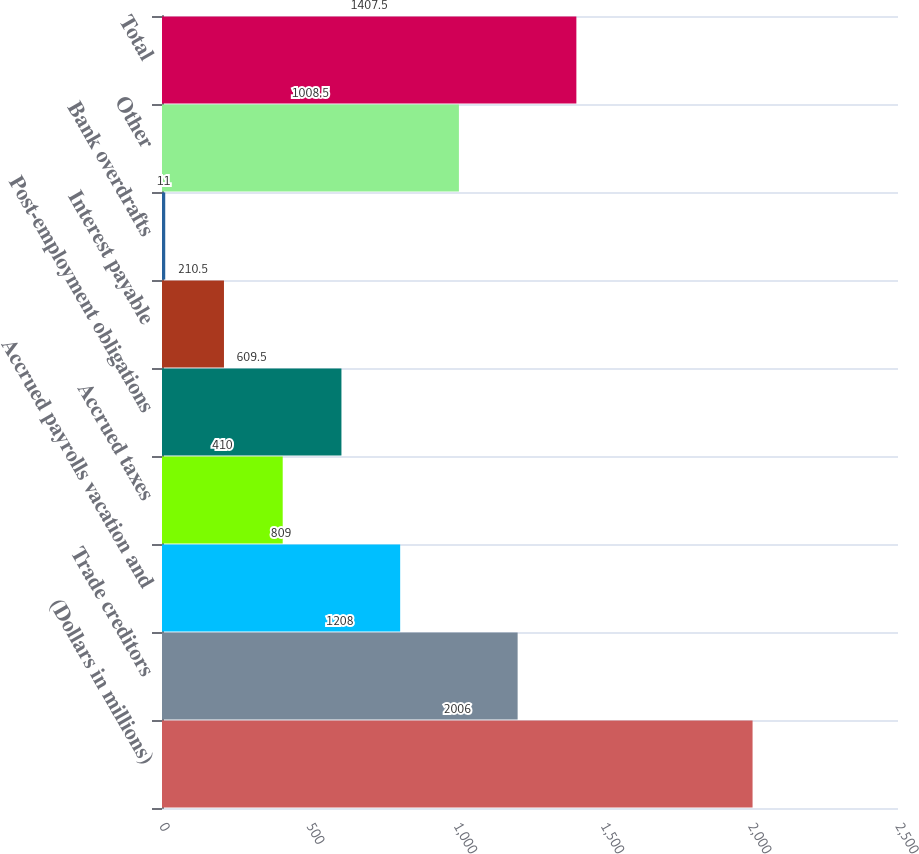<chart> <loc_0><loc_0><loc_500><loc_500><bar_chart><fcel>(Dollars in millions)<fcel>Trade creditors<fcel>Accrued payrolls vacation and<fcel>Accrued taxes<fcel>Post-employment obligations<fcel>Interest payable<fcel>Bank overdrafts<fcel>Other<fcel>Total<nl><fcel>2006<fcel>1208<fcel>809<fcel>410<fcel>609.5<fcel>210.5<fcel>11<fcel>1008.5<fcel>1407.5<nl></chart> 